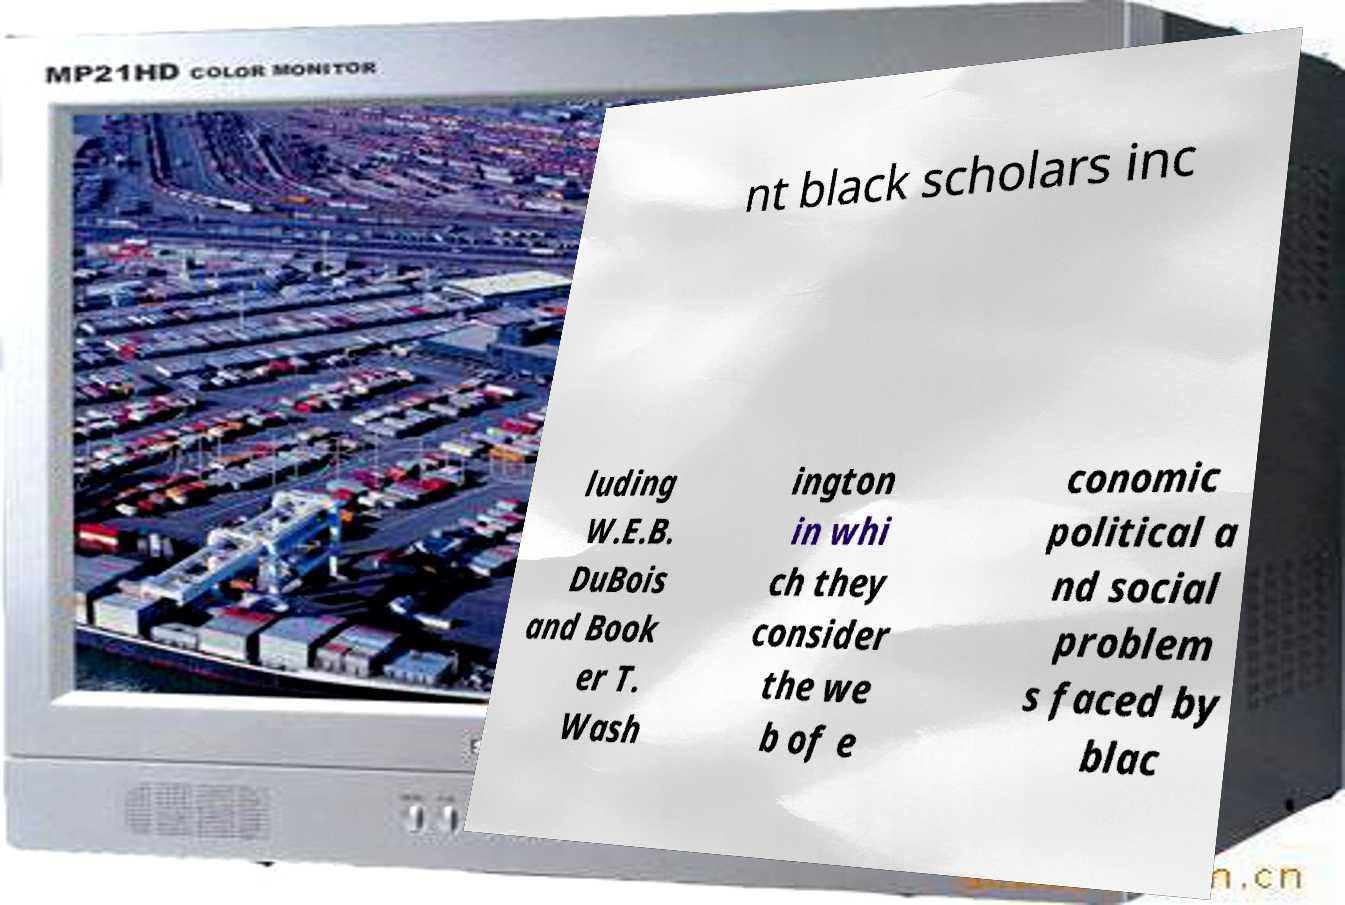I need the written content from this picture converted into text. Can you do that? nt black scholars inc luding W.E.B. DuBois and Book er T. Wash ington in whi ch they consider the we b of e conomic political a nd social problem s faced by blac 